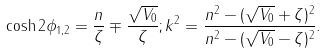<formula> <loc_0><loc_0><loc_500><loc_500>\cosh 2 \phi _ { 1 , 2 } = \frac { n } { \zeta } \mp \frac { \sqrt { V _ { 0 } } } { \zeta } ; k ^ { 2 } = \frac { n ^ { 2 } - ( \sqrt { V _ { 0 } } + \zeta ) ^ { 2 } } { n ^ { 2 } - ( \sqrt { V _ { 0 } } - \zeta ) ^ { 2 } } .</formula> 